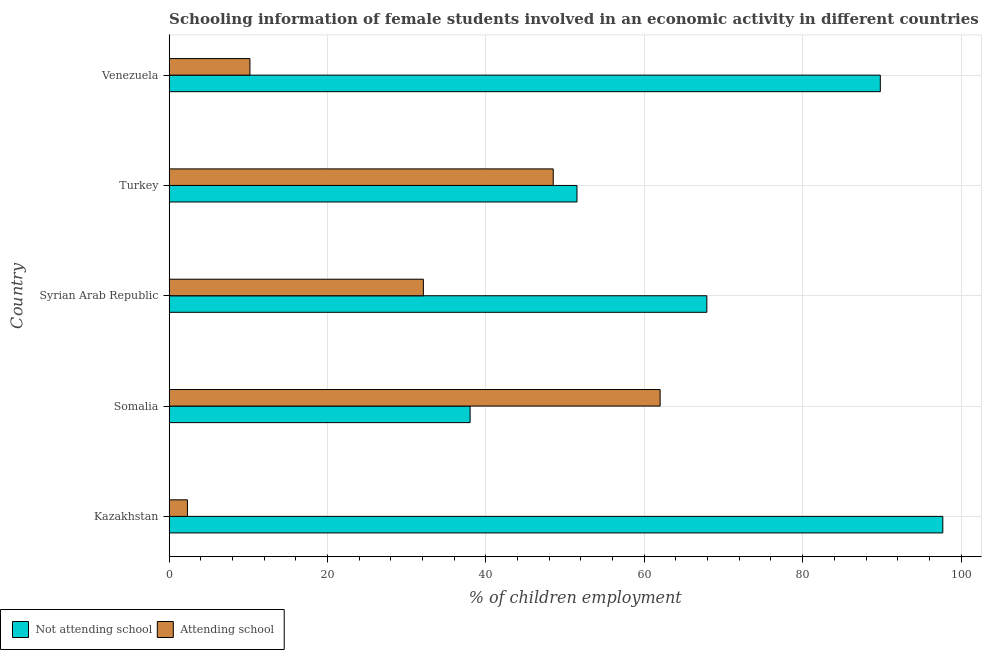How many different coloured bars are there?
Provide a short and direct response. 2. How many groups of bars are there?
Offer a terse response. 5. Are the number of bars on each tick of the Y-axis equal?
Your answer should be very brief. Yes. How many bars are there on the 5th tick from the bottom?
Keep it short and to the point. 2. What is the label of the 5th group of bars from the top?
Provide a short and direct response. Kazakhstan. In how many cases, is the number of bars for a given country not equal to the number of legend labels?
Your response must be concise. 0. What is the percentage of employed females who are not attending school in Venezuela?
Offer a terse response. 89.81. Across all countries, what is the minimum percentage of employed females who are not attending school?
Your answer should be very brief. 38. In which country was the percentage of employed females who are attending school maximum?
Provide a short and direct response. Somalia. In which country was the percentage of employed females who are attending school minimum?
Provide a short and direct response. Kazakhstan. What is the total percentage of employed females who are attending school in the graph?
Offer a terse response. 155.09. What is the difference between the percentage of employed females who are not attending school in Somalia and that in Syrian Arab Republic?
Provide a short and direct response. -29.9. What is the difference between the percentage of employed females who are not attending school in Somalia and the percentage of employed females who are attending school in Venezuela?
Your answer should be very brief. 27.81. What is the average percentage of employed females who are attending school per country?
Offer a very short reply. 31.02. What is the difference between the percentage of employed females who are attending school and percentage of employed females who are not attending school in Syrian Arab Republic?
Offer a very short reply. -35.8. What is the ratio of the percentage of employed females who are attending school in Syrian Arab Republic to that in Venezuela?
Keep it short and to the point. 3.15. Is the percentage of employed females who are not attending school in Turkey less than that in Venezuela?
Offer a terse response. Yes. What is the difference between the highest and the second highest percentage of employed females who are attending school?
Provide a succinct answer. 13.5. What is the difference between the highest and the lowest percentage of employed females who are attending school?
Provide a succinct answer. 59.7. In how many countries, is the percentage of employed females who are attending school greater than the average percentage of employed females who are attending school taken over all countries?
Provide a short and direct response. 3. What does the 2nd bar from the top in Kazakhstan represents?
Make the answer very short. Not attending school. What does the 2nd bar from the bottom in Turkey represents?
Your answer should be very brief. Attending school. Are all the bars in the graph horizontal?
Provide a short and direct response. Yes. Are the values on the major ticks of X-axis written in scientific E-notation?
Give a very brief answer. No. Does the graph contain grids?
Ensure brevity in your answer.  Yes. Where does the legend appear in the graph?
Give a very brief answer. Bottom left. How many legend labels are there?
Your answer should be compact. 2. What is the title of the graph?
Offer a terse response. Schooling information of female students involved in an economic activity in different countries. Does "National Tourists" appear as one of the legend labels in the graph?
Offer a terse response. No. What is the label or title of the X-axis?
Your answer should be very brief. % of children employment. What is the label or title of the Y-axis?
Your answer should be compact. Country. What is the % of children employment in Not attending school in Kazakhstan?
Provide a short and direct response. 97.7. What is the % of children employment in Attending school in Kazakhstan?
Make the answer very short. 2.3. What is the % of children employment in Attending school in Somalia?
Your answer should be compact. 62. What is the % of children employment of Not attending school in Syrian Arab Republic?
Your answer should be compact. 67.9. What is the % of children employment of Attending school in Syrian Arab Republic?
Offer a very short reply. 32.1. What is the % of children employment in Not attending school in Turkey?
Provide a short and direct response. 51.5. What is the % of children employment in Attending school in Turkey?
Ensure brevity in your answer.  48.5. What is the % of children employment of Not attending school in Venezuela?
Your answer should be very brief. 89.81. What is the % of children employment of Attending school in Venezuela?
Provide a short and direct response. 10.19. Across all countries, what is the maximum % of children employment of Not attending school?
Your response must be concise. 97.7. Across all countries, what is the minimum % of children employment of Not attending school?
Ensure brevity in your answer.  38. Across all countries, what is the minimum % of children employment of Attending school?
Ensure brevity in your answer.  2.3. What is the total % of children employment of Not attending school in the graph?
Offer a very short reply. 344.91. What is the total % of children employment in Attending school in the graph?
Your answer should be very brief. 155.09. What is the difference between the % of children employment in Not attending school in Kazakhstan and that in Somalia?
Offer a very short reply. 59.7. What is the difference between the % of children employment in Attending school in Kazakhstan and that in Somalia?
Provide a succinct answer. -59.7. What is the difference between the % of children employment of Not attending school in Kazakhstan and that in Syrian Arab Republic?
Provide a succinct answer. 29.8. What is the difference between the % of children employment in Attending school in Kazakhstan and that in Syrian Arab Republic?
Make the answer very short. -29.8. What is the difference between the % of children employment of Not attending school in Kazakhstan and that in Turkey?
Your answer should be very brief. 46.2. What is the difference between the % of children employment of Attending school in Kazakhstan and that in Turkey?
Your answer should be compact. -46.2. What is the difference between the % of children employment in Not attending school in Kazakhstan and that in Venezuela?
Offer a terse response. 7.89. What is the difference between the % of children employment in Attending school in Kazakhstan and that in Venezuela?
Make the answer very short. -7.89. What is the difference between the % of children employment in Not attending school in Somalia and that in Syrian Arab Republic?
Provide a succinct answer. -29.9. What is the difference between the % of children employment of Attending school in Somalia and that in Syrian Arab Republic?
Ensure brevity in your answer.  29.9. What is the difference between the % of children employment of Attending school in Somalia and that in Turkey?
Your answer should be compact. 13.5. What is the difference between the % of children employment in Not attending school in Somalia and that in Venezuela?
Give a very brief answer. -51.81. What is the difference between the % of children employment in Attending school in Somalia and that in Venezuela?
Your answer should be compact. 51.81. What is the difference between the % of children employment in Not attending school in Syrian Arab Republic and that in Turkey?
Keep it short and to the point. 16.4. What is the difference between the % of children employment in Attending school in Syrian Arab Republic and that in Turkey?
Give a very brief answer. -16.4. What is the difference between the % of children employment of Not attending school in Syrian Arab Republic and that in Venezuela?
Your response must be concise. -21.91. What is the difference between the % of children employment of Attending school in Syrian Arab Republic and that in Venezuela?
Your answer should be compact. 21.91. What is the difference between the % of children employment of Not attending school in Turkey and that in Venezuela?
Provide a succinct answer. -38.31. What is the difference between the % of children employment of Attending school in Turkey and that in Venezuela?
Your answer should be compact. 38.31. What is the difference between the % of children employment in Not attending school in Kazakhstan and the % of children employment in Attending school in Somalia?
Ensure brevity in your answer.  35.7. What is the difference between the % of children employment in Not attending school in Kazakhstan and the % of children employment in Attending school in Syrian Arab Republic?
Your response must be concise. 65.6. What is the difference between the % of children employment in Not attending school in Kazakhstan and the % of children employment in Attending school in Turkey?
Give a very brief answer. 49.2. What is the difference between the % of children employment in Not attending school in Kazakhstan and the % of children employment in Attending school in Venezuela?
Ensure brevity in your answer.  87.51. What is the difference between the % of children employment of Not attending school in Somalia and the % of children employment of Attending school in Syrian Arab Republic?
Give a very brief answer. 5.9. What is the difference between the % of children employment of Not attending school in Somalia and the % of children employment of Attending school in Venezuela?
Give a very brief answer. 27.81. What is the difference between the % of children employment in Not attending school in Syrian Arab Republic and the % of children employment in Attending school in Turkey?
Provide a succinct answer. 19.4. What is the difference between the % of children employment of Not attending school in Syrian Arab Republic and the % of children employment of Attending school in Venezuela?
Offer a terse response. 57.71. What is the difference between the % of children employment of Not attending school in Turkey and the % of children employment of Attending school in Venezuela?
Ensure brevity in your answer.  41.31. What is the average % of children employment of Not attending school per country?
Offer a very short reply. 68.98. What is the average % of children employment in Attending school per country?
Give a very brief answer. 31.02. What is the difference between the % of children employment of Not attending school and % of children employment of Attending school in Kazakhstan?
Provide a short and direct response. 95.4. What is the difference between the % of children employment of Not attending school and % of children employment of Attending school in Somalia?
Ensure brevity in your answer.  -24. What is the difference between the % of children employment in Not attending school and % of children employment in Attending school in Syrian Arab Republic?
Your answer should be compact. 35.8. What is the difference between the % of children employment in Not attending school and % of children employment in Attending school in Turkey?
Offer a terse response. 3. What is the difference between the % of children employment of Not attending school and % of children employment of Attending school in Venezuela?
Offer a terse response. 79.61. What is the ratio of the % of children employment in Not attending school in Kazakhstan to that in Somalia?
Give a very brief answer. 2.57. What is the ratio of the % of children employment in Attending school in Kazakhstan to that in Somalia?
Offer a terse response. 0.04. What is the ratio of the % of children employment of Not attending school in Kazakhstan to that in Syrian Arab Republic?
Keep it short and to the point. 1.44. What is the ratio of the % of children employment in Attending school in Kazakhstan to that in Syrian Arab Republic?
Keep it short and to the point. 0.07. What is the ratio of the % of children employment in Not attending school in Kazakhstan to that in Turkey?
Keep it short and to the point. 1.9. What is the ratio of the % of children employment of Attending school in Kazakhstan to that in Turkey?
Your answer should be very brief. 0.05. What is the ratio of the % of children employment in Not attending school in Kazakhstan to that in Venezuela?
Your answer should be compact. 1.09. What is the ratio of the % of children employment of Attending school in Kazakhstan to that in Venezuela?
Provide a short and direct response. 0.23. What is the ratio of the % of children employment in Not attending school in Somalia to that in Syrian Arab Republic?
Provide a succinct answer. 0.56. What is the ratio of the % of children employment in Attending school in Somalia to that in Syrian Arab Republic?
Give a very brief answer. 1.93. What is the ratio of the % of children employment in Not attending school in Somalia to that in Turkey?
Give a very brief answer. 0.74. What is the ratio of the % of children employment of Attending school in Somalia to that in Turkey?
Ensure brevity in your answer.  1.28. What is the ratio of the % of children employment of Not attending school in Somalia to that in Venezuela?
Provide a succinct answer. 0.42. What is the ratio of the % of children employment in Attending school in Somalia to that in Venezuela?
Offer a very short reply. 6.08. What is the ratio of the % of children employment of Not attending school in Syrian Arab Republic to that in Turkey?
Offer a very short reply. 1.32. What is the ratio of the % of children employment of Attending school in Syrian Arab Republic to that in Turkey?
Provide a short and direct response. 0.66. What is the ratio of the % of children employment in Not attending school in Syrian Arab Republic to that in Venezuela?
Your response must be concise. 0.76. What is the ratio of the % of children employment in Attending school in Syrian Arab Republic to that in Venezuela?
Keep it short and to the point. 3.15. What is the ratio of the % of children employment in Not attending school in Turkey to that in Venezuela?
Provide a succinct answer. 0.57. What is the ratio of the % of children employment in Attending school in Turkey to that in Venezuela?
Keep it short and to the point. 4.76. What is the difference between the highest and the second highest % of children employment of Not attending school?
Your answer should be very brief. 7.89. What is the difference between the highest and the second highest % of children employment in Attending school?
Provide a succinct answer. 13.5. What is the difference between the highest and the lowest % of children employment of Not attending school?
Make the answer very short. 59.7. What is the difference between the highest and the lowest % of children employment in Attending school?
Make the answer very short. 59.7. 